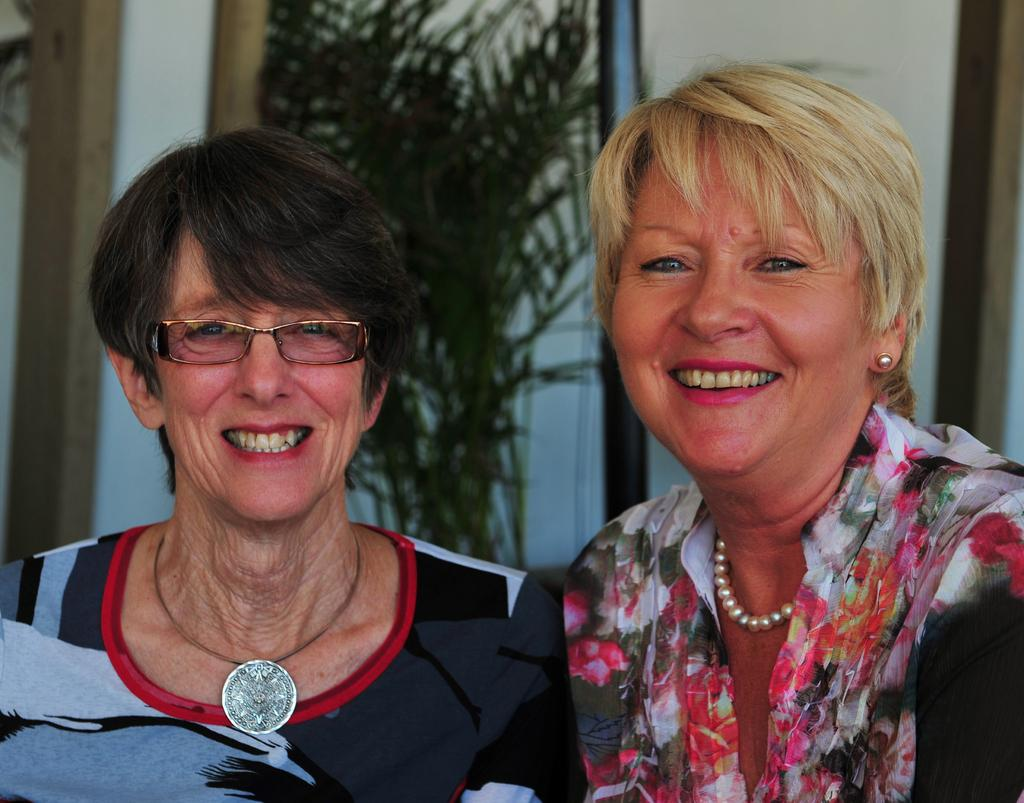How many women are in the image? There are two women in the image. What expressions do the women have? Both women are smiling. Can you describe one of the women's features? One of the women is wearing spectacles. What can be seen in the background of the image? There is a plant in the background of the image. What is beside the plant in the image? There is a wall beside the plant. What type of pot is the toad sitting on in the image? There is no pot or toad present in the image. What kind of beast can be seen interacting with the women in the image? There is no beast present in the image; only the two women and the plant are visible. 